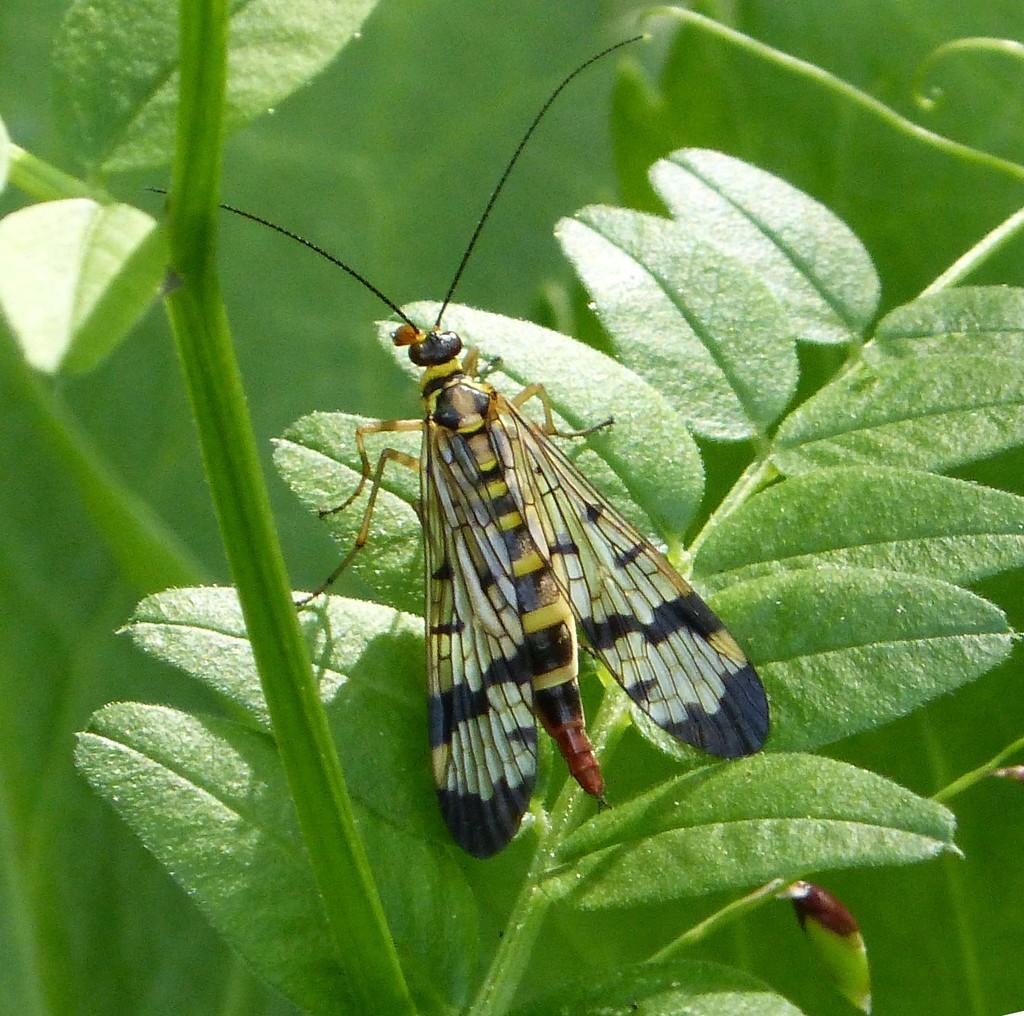What type of living organism can be seen in the image? There is a plant with leaves in the image. What other living organism can be seen in the image? There is an insect in the image. Can you describe the insect's physical features? The insect has wings, legs, an abdomen, and antennae. What type of pleasure can be seen being experienced by the hill in the image? There is no hill present in the image, and therefore no pleasure can be experienced by it. Can you describe the butter's role in the image? There is no butter present in the image, so its role cannot be described. 